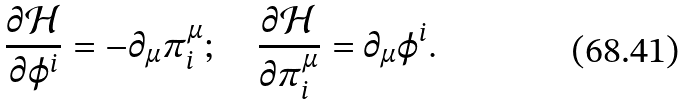Convert formula to latex. <formula><loc_0><loc_0><loc_500><loc_500>\frac { \partial \mathcal { H } } { \partial \varphi ^ { i } } = - \partial _ { \mu } \pi ^ { \mu } _ { i } ; \quad \frac { \partial \mathcal { H } } { \partial \pi ^ { \mu } _ { i } } = \partial _ { \mu } \varphi ^ { i } .</formula> 